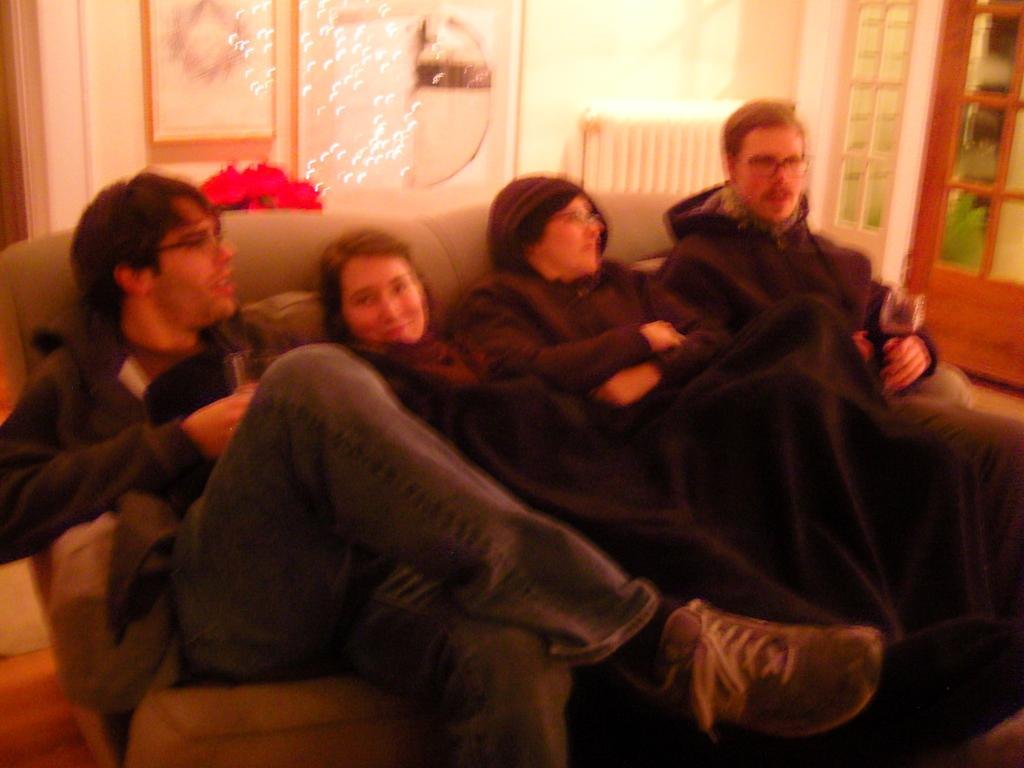How many people are in the image? There are four people in the image. What are the people doing in the image? The people are sitting on a couch. Can you describe the surroundings in the image? There is a window on the right side of the image. What type of park can be seen through the window in the image? There is no park visible through the window in the image. 